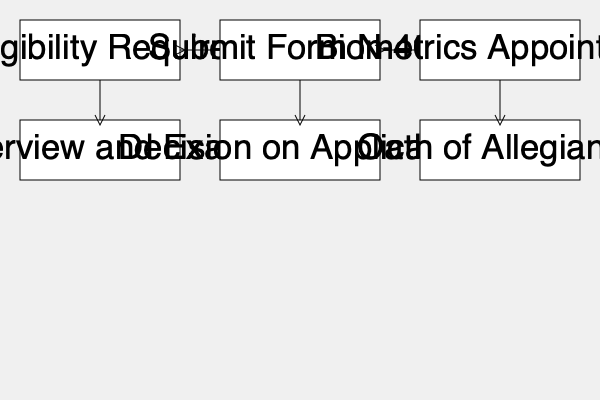According to the naturalization process flowchart, what step immediately follows the "Interview and Exam" stage? To answer this question, let's follow the steps in the naturalization process flowchart:

1. The process begins with "Meet Eligibility Requirements."
2. It then moves to "Submit Form N-400."
3. Next is the "Biometrics Appointment."
4. The fourth step is "Interview and Exam."
5. After the "Interview and Exam," the flowchart shows an arrow pointing to "Decision on Application."
6. The final step shown is "Oath of Allegiance."

Therefore, based on the flowchart, the step that immediately follows the "Interview and Exam" stage is the "Decision on Application."
Answer: Decision on Application 